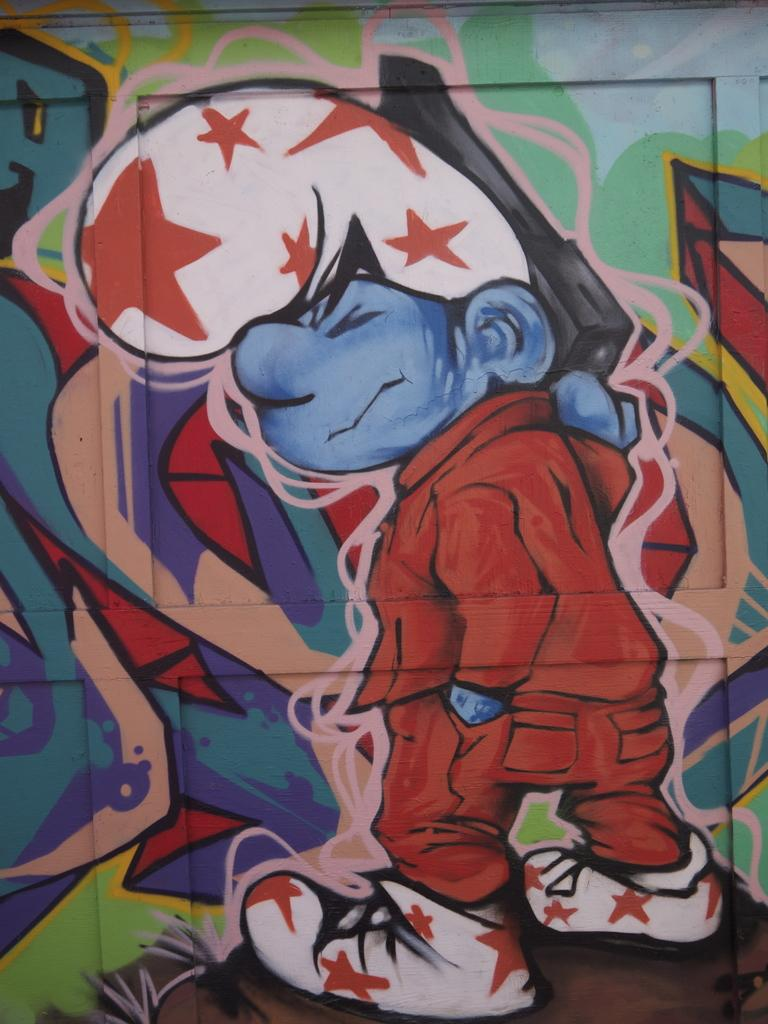What type of character is depicted in the painting in the image? There is a painting of a smurf in the image. Can you describe any other design or pattern in the image? There is a design on an object in the image. How does the smurf wash their skin in the image? There is no indication in the image that the smurf is washing their skin, as it is a painting and not a live scene. 